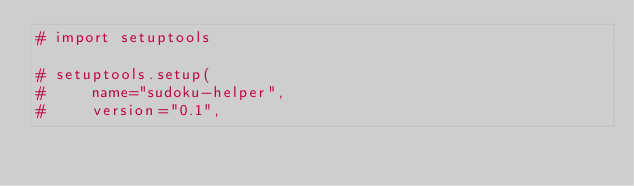<code> <loc_0><loc_0><loc_500><loc_500><_Python_># import setuptools

# setuptools.setup(
#     name="sudoku-helper",
#     version="0.1",</code> 